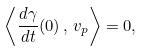<formula> <loc_0><loc_0><loc_500><loc_500>\left \langle \frac { d \gamma } { d t } ( 0 ) \, , \, v _ { p } \right \rangle = 0 ,</formula> 